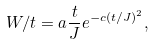Convert formula to latex. <formula><loc_0><loc_0><loc_500><loc_500>W / t = a \frac { t } { J } e ^ { - c ( t / J ) ^ { 2 } } ,</formula> 